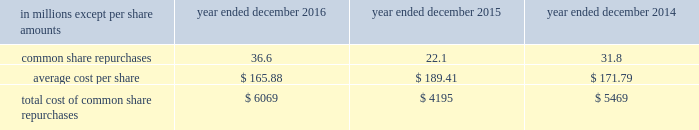The goldman sachs group , inc .
And subsidiaries notes to consolidated financial statements in connection with the firm 2019s prime brokerage and clearing businesses , the firm agrees to clear and settle on behalf of its clients the transactions entered into by them with other brokerage firms .
The firm 2019s obligations in respect of such transactions are secured by the assets in the client 2019s account as well as any proceeds received from the transactions cleared and settled by the firm on behalf of the client .
In connection with joint venture investments , the firm may issue loan guarantees under which it may be liable in the event of fraud , misappropriation , environmental liabilities and certain other matters involving the borrower .
The firm is unable to develop an estimate of the maximum payout under these guarantees and indemnifications .
However , management believes that it is unlikely the firm will have to make any material payments under these arrangements , and no material liabilities related to these guarantees and indemnifications have been recognized in the consolidated statements of financial condition as of december 2016 and december 2015 .
Other representations , warranties and indemnifications .
The firm provides representations and warranties to counterparties in connection with a variety of commercial transactions and occasionally indemnifies them against potential losses caused by the breach of those representations and warranties .
The firm may also provide indemnifications protecting against changes in or adverse application of certain u.s .
Tax laws in connection with ordinary-course transactions such as securities issuances , borrowings or derivatives .
In addition , the firm may provide indemnifications to some counterparties to protect them in the event additional taxes are owed or payments are withheld , due either to a change in or an adverse application of certain non-u.s .
Tax laws .
These indemnifications generally are standard contractual terms and are entered into in the ordinary course of business .
Generally , there are no stated or notional amounts included in these indemnifications , and the contingencies triggering the obligation to indemnify are not expected to occur .
The firm is unable to develop an estimate of the maximum payout under these guarantees and indemnifications .
However , management believes that it is unlikely the firm will have to make any material payments under these arrangements , and no material liabilities related to these arrangements have been recognized in the consolidated statements of financial condition as of december 2016 and december 2015 .
Guarantees of subsidiaries .
Group inc .
Fully and unconditionally guarantees the securities issued by gs finance corp. , a wholly-owned finance subsidiary of the group inc .
Has guaranteed the payment obligations of goldman , sachs & co .
( gs&co. ) and gs bank usa , subject to certain exceptions .
In addition , group inc .
Guarantees many of the obligations of its other consolidated subsidiaries on a transaction-by- transaction basis , as negotiated with counterparties .
Group inc .
Is unable to develop an estimate of the maximum payout under its subsidiary guarantees ; however , because these guaranteed obligations are also obligations of consolidated subsidiaries , group inc . 2019s liabilities as guarantor are not separately disclosed .
Note 19 .
Shareholders 2019 equity common equity dividends declared per common share were $ 2.60 in 2016 , $ 2.55 in 2015 and $ 2.25 in 2014 .
On january 17 , 2017 , group inc .
Declared a dividend of $ 0.65 per common share to be paid on march 30 , 2017 to common shareholders of record on march 2 , 2017 .
The firm 2019s share repurchase program is intended to help maintain the appropriate level of common equity .
The share repurchase program is effected primarily through regular open-market purchases ( which may include repurchase plans designed to comply with rule 10b5-1 ) , the amounts and timing of which are determined primarily by the firm 2019s current and projected capital position , but which may also be influenced by general market conditions and the prevailing price and trading volumes of the firm 2019s common stock .
Prior to repurchasing common stock , the firm must receive confirmation that the federal reserve board does not object to such capital actions .
The table below presents the amount of common stock repurchased by the firm under the share repurchase program. .
172 goldman sachs 2016 form 10-k .
What was the difference in millions between the total cost of common shares repurchases from 2015 to 2016? 
Computations: (4195 - 5469)
Answer: -1274.0. 